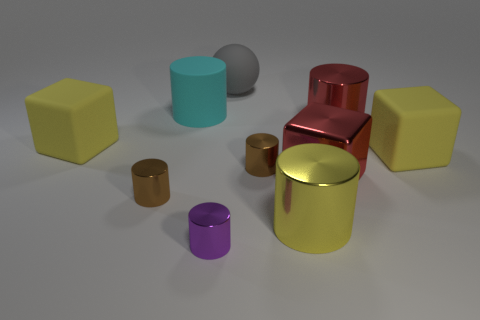Are there any other things that are the same shape as the gray thing?
Keep it short and to the point. No. Is there a brown thing that has the same size as the cyan object?
Provide a succinct answer. No. What is the tiny purple object that is in front of the large cyan rubber thing made of?
Offer a very short reply. Metal. What is the color of the block that is made of the same material as the purple thing?
Provide a short and direct response. Red. What number of metallic things are gray spheres or red things?
Offer a terse response. 2. What shape is the gray thing that is the same size as the shiny block?
Make the answer very short. Sphere. What number of objects are either large red metal things on the left side of the red cylinder or big yellow cubes that are in front of the large cyan object?
Your answer should be compact. 3. There is a gray object that is the same size as the yellow shiny cylinder; what is its material?
Offer a very short reply. Rubber. What number of other objects are there of the same material as the big cyan cylinder?
Provide a succinct answer. 3. Are there an equal number of small brown things on the left side of the cyan rubber cylinder and purple cylinders that are on the right side of the big red metal block?
Your answer should be very brief. No. 